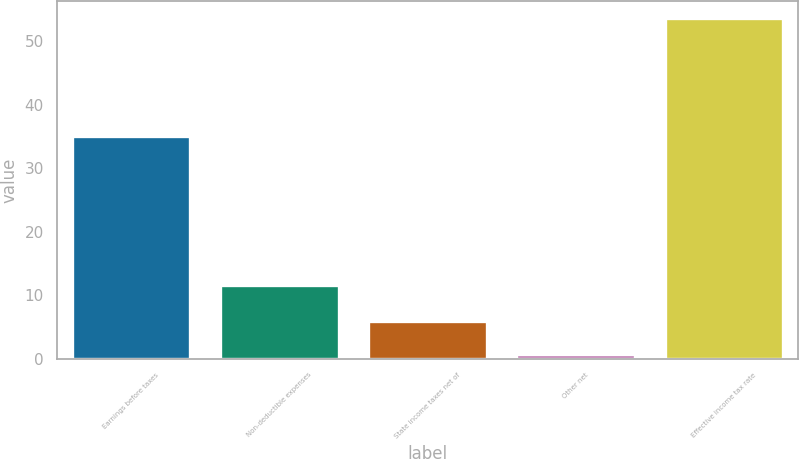Convert chart. <chart><loc_0><loc_0><loc_500><loc_500><bar_chart><fcel>Earnings before taxes<fcel>Non-deductible expenses<fcel>State income taxes net of<fcel>Other net<fcel>Effective income tax rate<nl><fcel>35<fcel>11.6<fcel>5.99<fcel>0.7<fcel>53.6<nl></chart> 